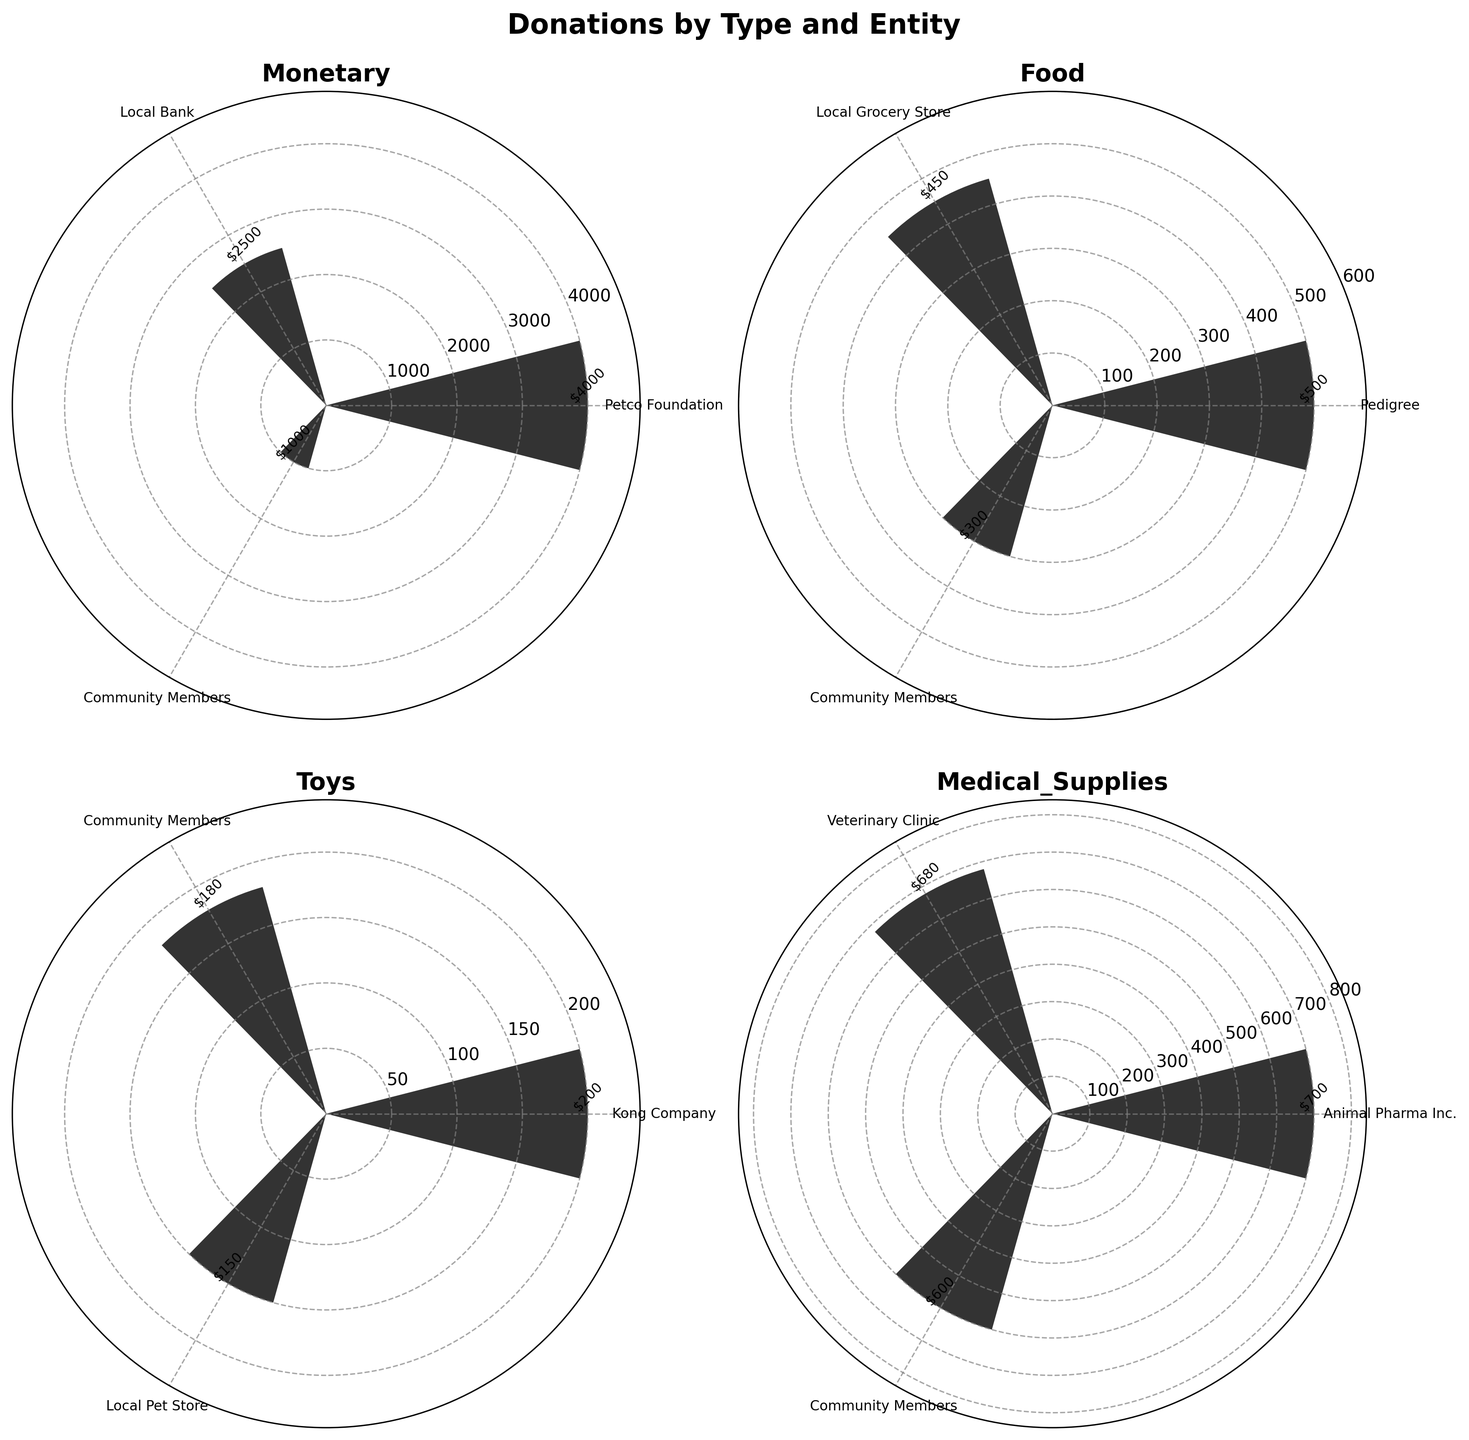Which entity contributed the highest amount in the "Monetary" donation type? The "Monetary" donation type subplot shows three bars with entities and their respective amounts. The highest bar corresponds to the "Petco Foundation" at $4000.
Answer: Petco Foundation What's the total amount donated for "Food"? Summing up the amounts in the "Food" donation type subplot: 500 (Pedigree) + 450 (Local Grocery Store) + 300 (Community Members) = 1250.
Answer: $1250 Which donation type has the most contributors? Each subplot represents a donation type and shows the number of entities. By counting the bars in each subplot, "Medical Supplies" has three contributors, more than any other type.
Answer: Medical Supplies What is the average donation amount of "Toys"? The amounts in the "Toys" donation type subplot are 200 (Kong Company), 180 (Community Members), and 150 (Local Pet Store). Summing them gives 530. The average is 530/3 = 176.67.
Answer: $176.67 How much more did "Animal Pharma Inc." donate compared to the "Veterinary Clinic" in "Medical Supplies"? In the "Medical Supplies" subplot, "Animal Pharma Inc." donated 700, and the "Veterinary Clinic" donated 680. The difference is 700 - 680.
Answer: $20 Which entity is the smallest contributor in the "Monetary" donation type? The "Monetary" donation type subplot shows three bars. The shortest bar corresponds to "Community Members" at $1000.
Answer: Community Members What is the combined contribution of the "Community Members" across all donation types? Summing up the contributions from "Community Members" across subplots: 1000 (Monetary) + 300 (Food) + 180 (Toys) + 600 (Medical Supplies) = 2080.
Answer: $2080 How does the contribution from "Local Bank" compare to "Local Grocery Store"? The "Local Bank" contributes 2500 (Monetary) and "Local Grocery Store" contributes 450 (Food). The difference is 2500 - 450 = 2050, indicating "Local Bank" contributes more.
Answer: $2050 more What percentage of total "Medical Supplies" donations is contributed by "Animal Pharma Inc."? Total "Medical Supplies" donations: 700 (Animal Pharma Inc.) + 680 (Veterinary Clinic) + 600 (Community Members) = 1980. Contribution by "Animal Pharma Inc." is 700. Percentage is (700/1980) * 100 = 35.35%.
Answer: 35.35% 